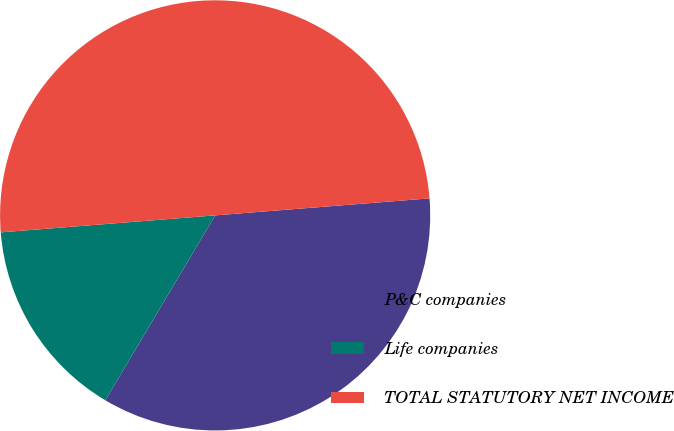Convert chart to OTSL. <chart><loc_0><loc_0><loc_500><loc_500><pie_chart><fcel>P&C companies<fcel>Life companies<fcel>TOTAL STATUTORY NET INCOME<nl><fcel>34.79%<fcel>15.21%<fcel>50.0%<nl></chart> 